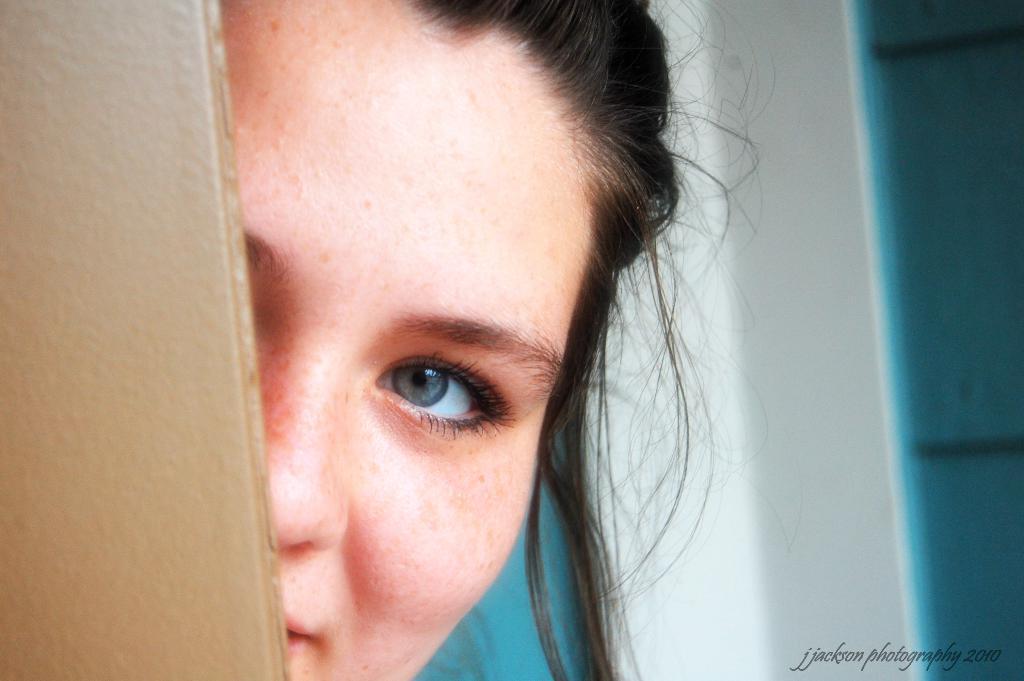Could you give a brief overview of what you see in this image? In this picture we can see a person's face, wall, some objects and at the bottom right corner we can see some text. 